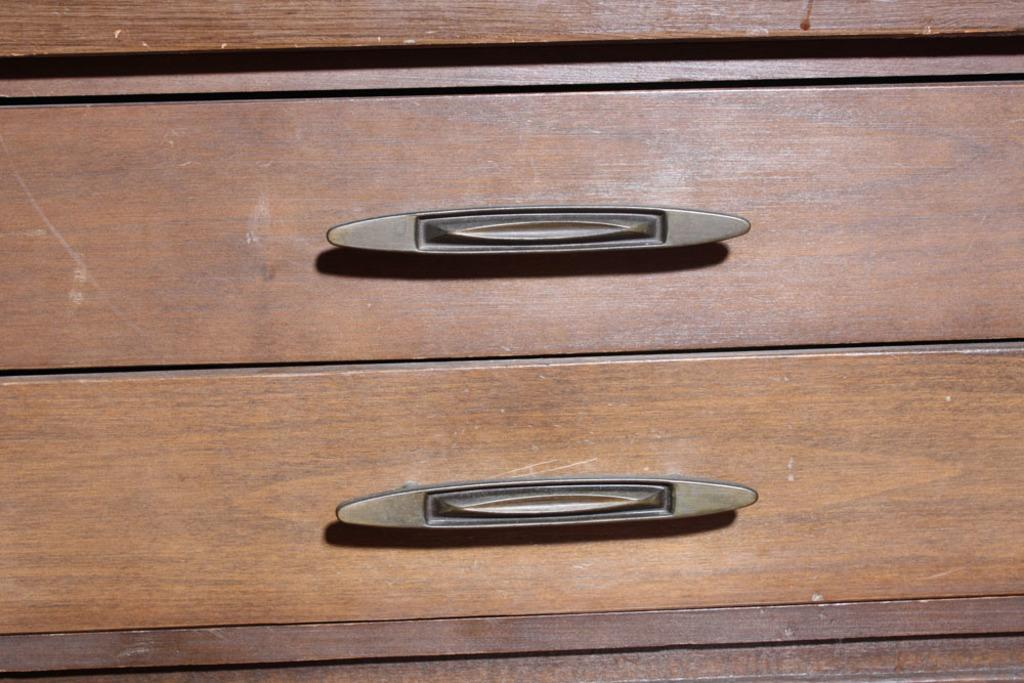What type of furniture is present in the image? There is a cupboard in the image. How many handles are on the cupboard? The cupboard has two handles. How many fish are swimming in the cupboard in the image? There are no fish present in the image, as it features a cupboard with two handles. 